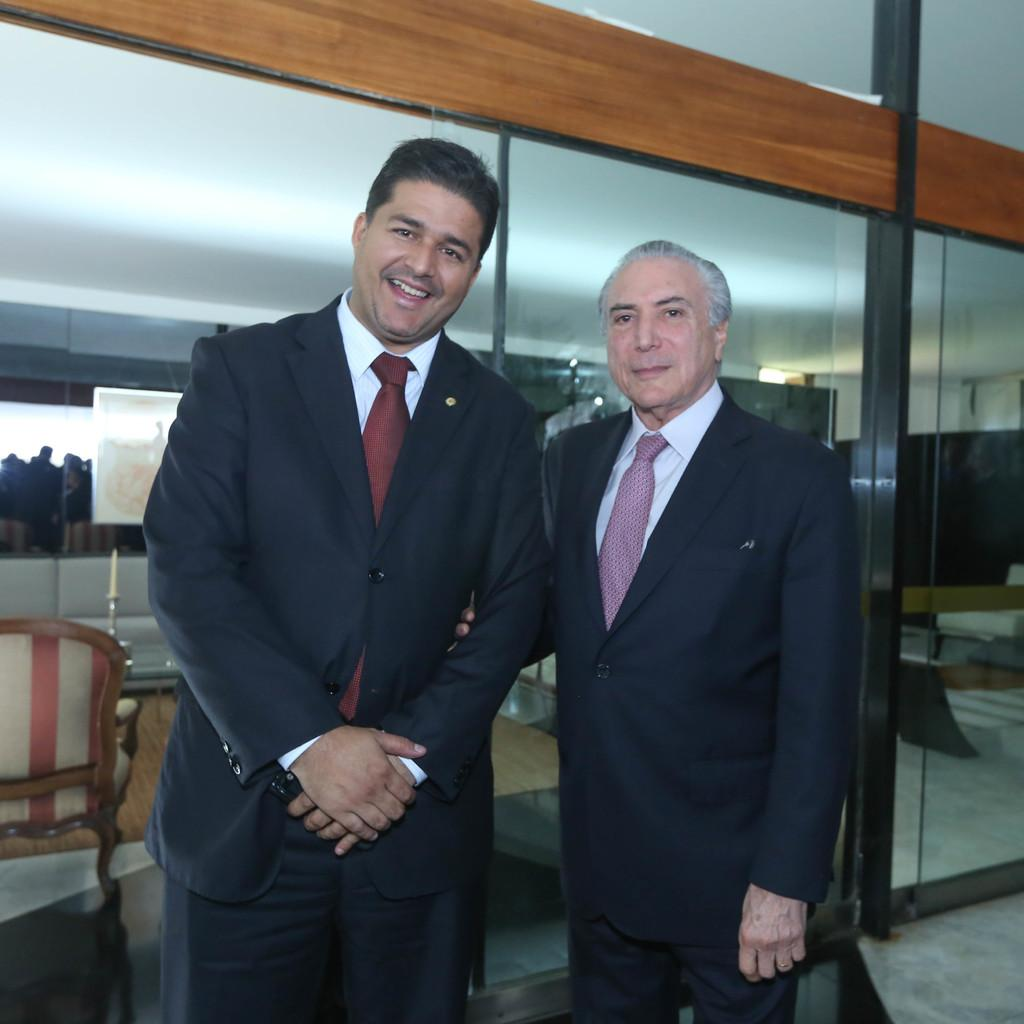What are the two people in the center of the image doing? The two people in the center of the image are standing and posing for the picture. What object can be seen in the image besides the people? There is a chair and a glass wall in the image. Are there any other people visible in the image? Yes, there are other people visible behind the two people posing for the picture. What type of jam is being spread on the glass wall in the image? There is no jam present in the image; it features two people posing for a picture with a chair and a glass wall. 